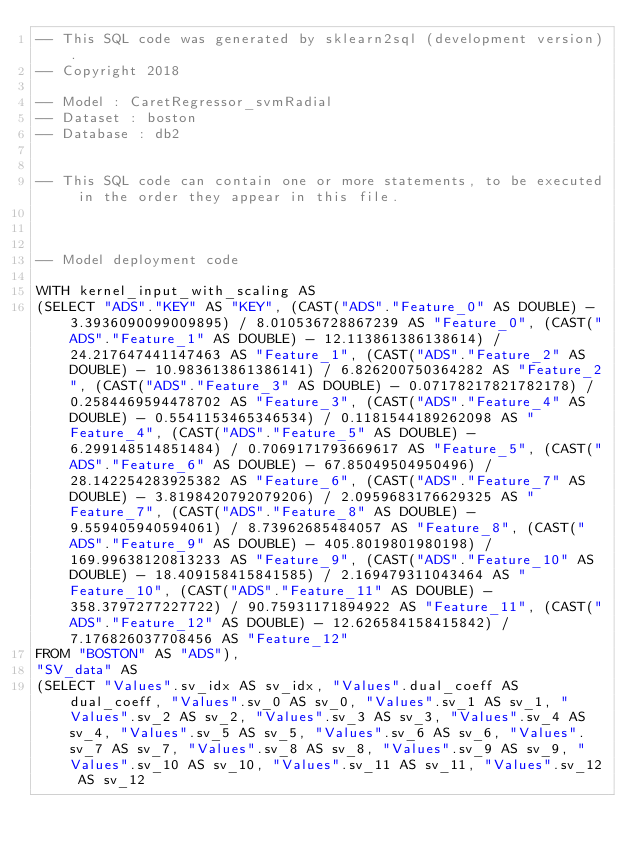<code> <loc_0><loc_0><loc_500><loc_500><_SQL_>-- This SQL code was generated by sklearn2sql (development version).
-- Copyright 2018

-- Model : CaretRegressor_svmRadial
-- Dataset : boston
-- Database : db2


-- This SQL code can contain one or more statements, to be executed in the order they appear in this file.



-- Model deployment code

WITH kernel_input_with_scaling AS 
(SELECT "ADS"."KEY" AS "KEY", (CAST("ADS"."Feature_0" AS DOUBLE) - 3.3936090099009895) / 8.010536728867239 AS "Feature_0", (CAST("ADS"."Feature_1" AS DOUBLE) - 12.113861386138614) / 24.217647441147463 AS "Feature_1", (CAST("ADS"."Feature_2" AS DOUBLE) - 10.983613861386141) / 6.826200750364282 AS "Feature_2", (CAST("ADS"."Feature_3" AS DOUBLE) - 0.07178217821782178) / 0.2584469594478702 AS "Feature_3", (CAST("ADS"."Feature_4" AS DOUBLE) - 0.5541153465346534) / 0.1181544189262098 AS "Feature_4", (CAST("ADS"."Feature_5" AS DOUBLE) - 6.299148514851484) / 0.7069171793669617 AS "Feature_5", (CAST("ADS"."Feature_6" AS DOUBLE) - 67.85049504950496) / 28.142254283925382 AS "Feature_6", (CAST("ADS"."Feature_7" AS DOUBLE) - 3.8198420792079206) / 2.0959683176629325 AS "Feature_7", (CAST("ADS"."Feature_8" AS DOUBLE) - 9.559405940594061) / 8.73962685484057 AS "Feature_8", (CAST("ADS"."Feature_9" AS DOUBLE) - 405.8019801980198) / 169.99638120813233 AS "Feature_9", (CAST("ADS"."Feature_10" AS DOUBLE) - 18.409158415841585) / 2.169479311043464 AS "Feature_10", (CAST("ADS"."Feature_11" AS DOUBLE) - 358.3797277227722) / 90.75931171894922 AS "Feature_11", (CAST("ADS"."Feature_12" AS DOUBLE) - 12.626584158415842) / 7.176826037708456 AS "Feature_12" 
FROM "BOSTON" AS "ADS"), 
"SV_data" AS 
(SELECT "Values".sv_idx AS sv_idx, "Values".dual_coeff AS dual_coeff, "Values".sv_0 AS sv_0, "Values".sv_1 AS sv_1, "Values".sv_2 AS sv_2, "Values".sv_3 AS sv_3, "Values".sv_4 AS sv_4, "Values".sv_5 AS sv_5, "Values".sv_6 AS sv_6, "Values".sv_7 AS sv_7, "Values".sv_8 AS sv_8, "Values".sv_9 AS sv_9, "Values".sv_10 AS sv_10, "Values".sv_11 AS sv_11, "Values".sv_12 AS sv_12 </code> 